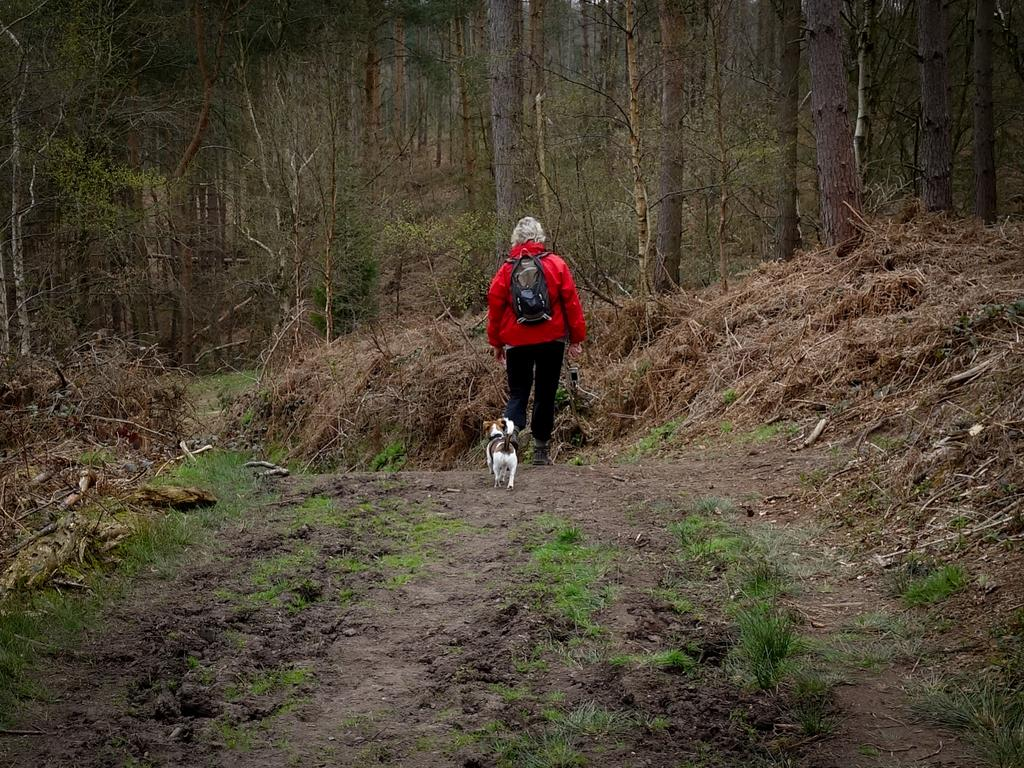What is the person in the image doing? The person in the image is walking. What is the person carrying while walking? The person is carrying a bag. Can you describe the environment in the image? Green grass and trees are visible in the image. Are there any other living creatures in the image besides the person? Yes, there is a dog behind the person. What type of grass can be seen in the image? Green grass and dried grass are present in the image. What type of fan is being used by the person in the image? There is no fan present in the image. What is the person carrying in the basket while walking? There is no basket present in the image; the person is carrying a bag. 